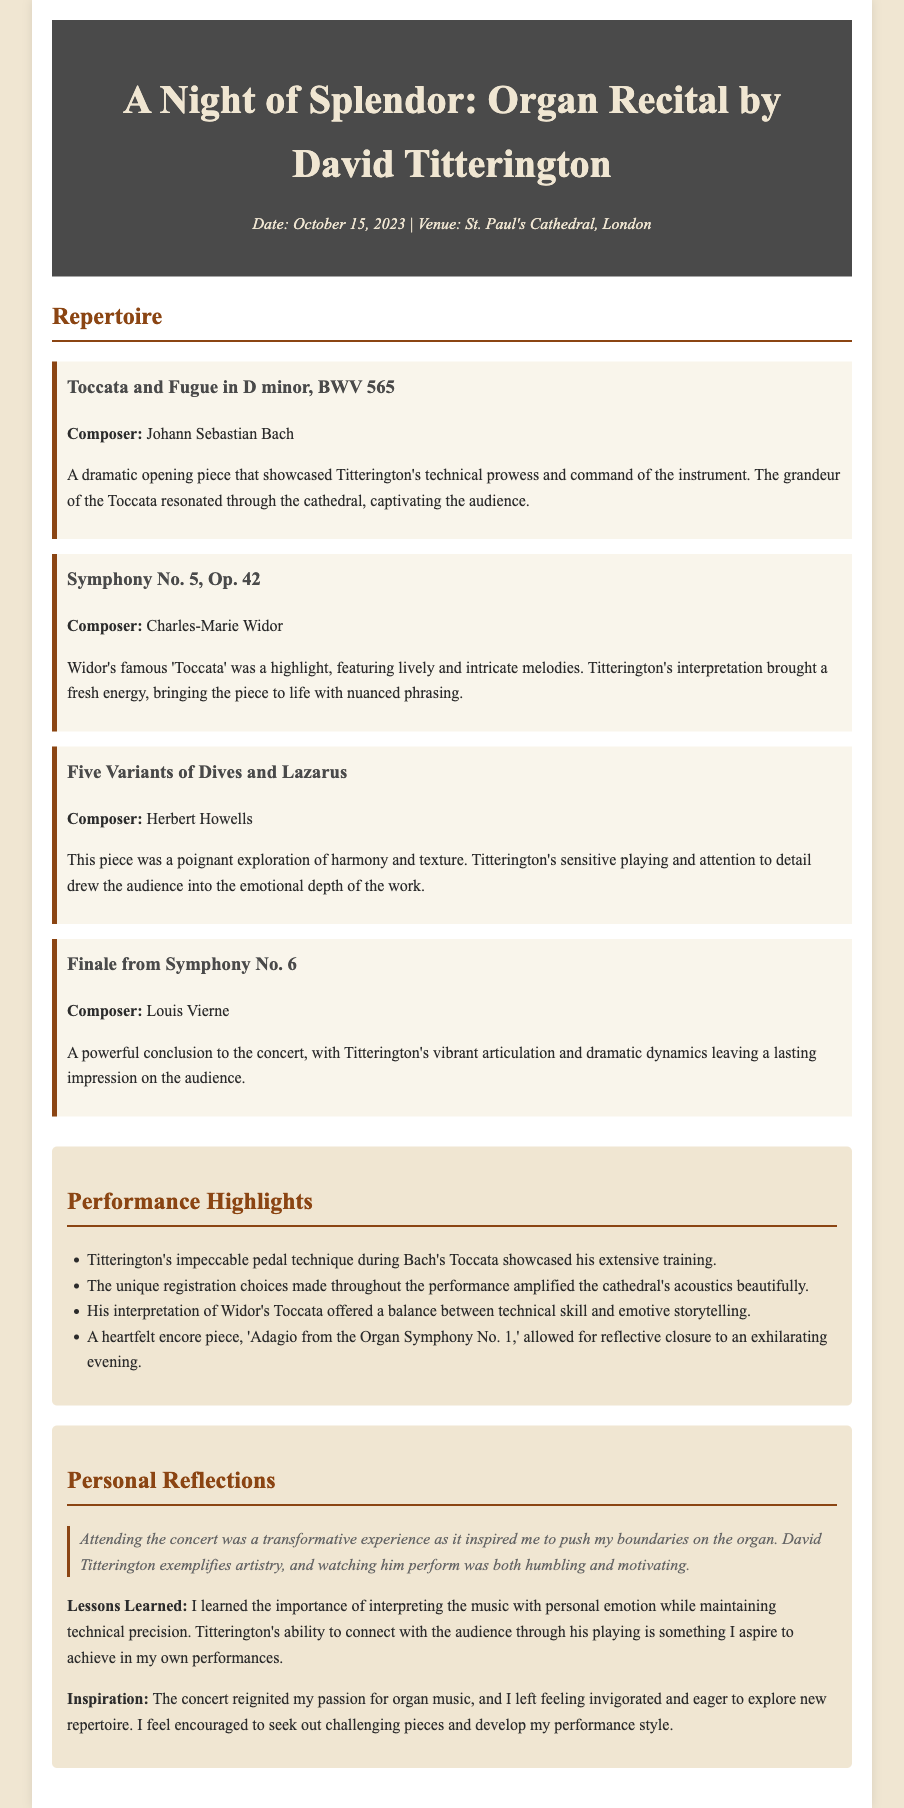What is the title of the concert? The title of the concert is mentioned in the header section of the document.
Answer: A Night of Splendor: Organ Recital by David Titterington Who performed at the concert? The performer is specified in the title and header of the document.
Answer: David Titterington On what date did the concert take place? The date of the concert is provided in the meta section of the header.
Answer: October 15, 2023 Which venue hosted the organ recital? The venue is also included in the meta section of the header.
Answer: St. Paul's Cathedral, London What is the first piece performed? The first piece in the repertoire section provides this information.
Answer: Toccata and Fugue in D minor, BWV 565 Who composed the last piece performed? The name of the composer is given in the repertoire section for the last piece.
Answer: Louis Vierne What highlight involved Titterington's pedal technique? The performance highlight related to pedal technique is stated in the highlights section.
Answer: Impeccable pedal technique during Bach's Toccata What emotional aspect was emphasized in the personal reflections? Personal reflections discuss the emotional connection and experience during the concert.
Answer: Inspired to push my boundaries on the organ Which piece served as the encore? The encore is mentioned in the highlights section, specifying the title.
Answer: Adagio from the Organ Symphony No. 1 